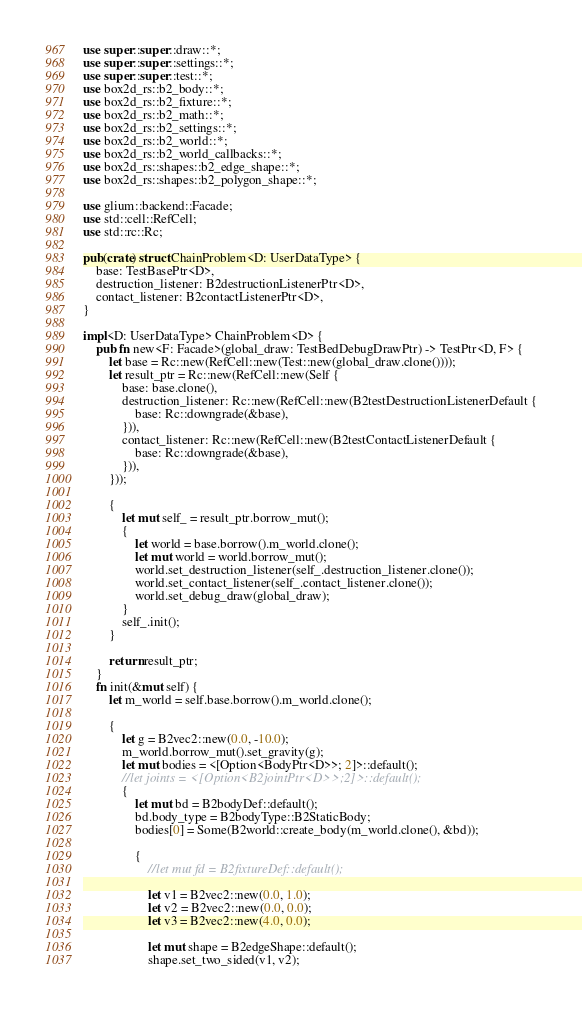Convert code to text. <code><loc_0><loc_0><loc_500><loc_500><_Rust_>use super::super::draw::*;
use super::super::settings::*;
use super::super::test::*;
use box2d_rs::b2_body::*;
use box2d_rs::b2_fixture::*;
use box2d_rs::b2_math::*;
use box2d_rs::b2_settings::*;
use box2d_rs::b2_world::*;
use box2d_rs::b2_world_callbacks::*;
use box2d_rs::shapes::b2_edge_shape::*;
use box2d_rs::shapes::b2_polygon_shape::*;

use glium::backend::Facade;
use std::cell::RefCell;
use std::rc::Rc;

pub(crate) struct ChainProblem<D: UserDataType> {
    base: TestBasePtr<D>,
    destruction_listener: B2destructionListenerPtr<D>,
    contact_listener: B2contactListenerPtr<D>,
}

impl<D: UserDataType> ChainProblem<D> {
    pub fn new<F: Facade>(global_draw: TestBedDebugDrawPtr) -> TestPtr<D, F> {
        let base = Rc::new(RefCell::new(Test::new(global_draw.clone())));
        let result_ptr = Rc::new(RefCell::new(Self {
            base: base.clone(),
            destruction_listener: Rc::new(RefCell::new(B2testDestructionListenerDefault {
                base: Rc::downgrade(&base),
            })),
            contact_listener: Rc::new(RefCell::new(B2testContactListenerDefault {
                base: Rc::downgrade(&base),
            })),
        }));

        {
            let mut self_ = result_ptr.borrow_mut();
            {
                let world = base.borrow().m_world.clone();
                let mut world = world.borrow_mut();
                world.set_destruction_listener(self_.destruction_listener.clone());
                world.set_contact_listener(self_.contact_listener.clone());
                world.set_debug_draw(global_draw);
            }
            self_.init();
        }

        return result_ptr;
    }
    fn init(&mut self) {
        let m_world = self.base.borrow().m_world.clone();

        {
            let g = B2vec2::new(0.0, -10.0);
            m_world.borrow_mut().set_gravity(g);
            let mut bodies = <[Option<BodyPtr<D>>; 2]>::default();
            //let joints = <[Option<B2jointPtr<D>>;2]>::default();
            {
                let mut bd = B2bodyDef::default();
                bd.body_type = B2bodyType::B2StaticBody;
                bodies[0] = Some(B2world::create_body(m_world.clone(), &bd));

                {
                    //let mut fd = B2fixtureDef::default();

                    let v1 = B2vec2::new(0.0, 1.0);
                    let v2 = B2vec2::new(0.0, 0.0);
                    let v3 = B2vec2::new(4.0, 0.0);

                    let mut shape = B2edgeShape::default();
                    shape.set_two_sided(v1, v2);</code> 